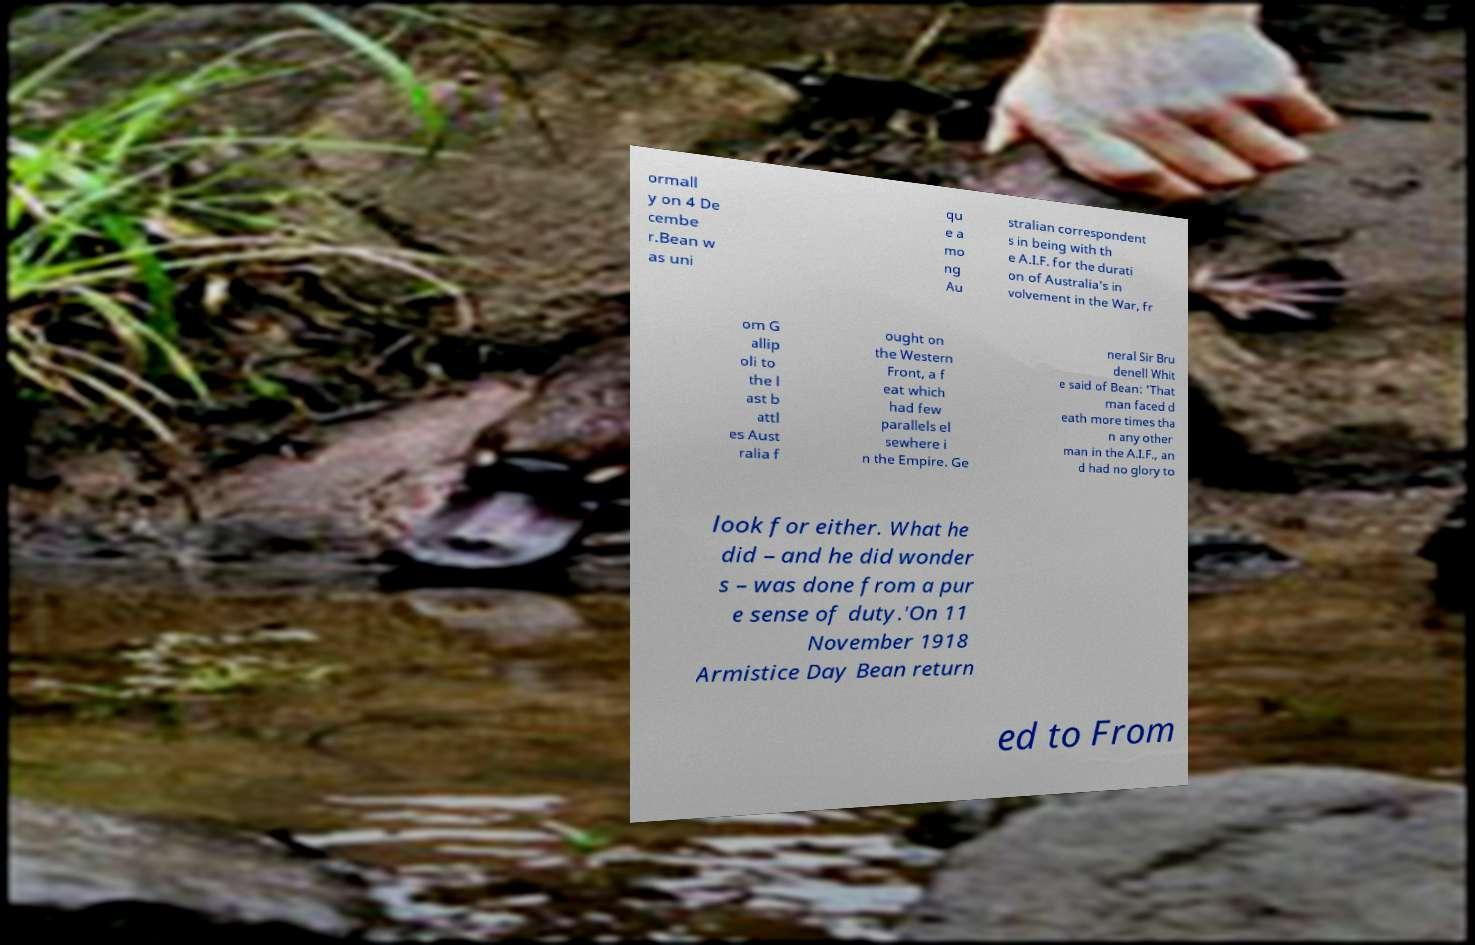For documentation purposes, I need the text within this image transcribed. Could you provide that? ormall y on 4 De cembe r.Bean w as uni qu e a mo ng Au stralian correspondent s in being with th e A.I.F. for the durati on of Australia's in volvement in the War, fr om G allip oli to the l ast b attl es Aust ralia f ought on the Western Front, a f eat which had few parallels el sewhere i n the Empire. Ge neral Sir Bru denell Whit e said of Bean: 'That man faced d eath more times tha n any other man in the A.I.F., an d had no glory to look for either. What he did – and he did wonder s – was done from a pur e sense of duty.'On 11 November 1918 Armistice Day Bean return ed to From 